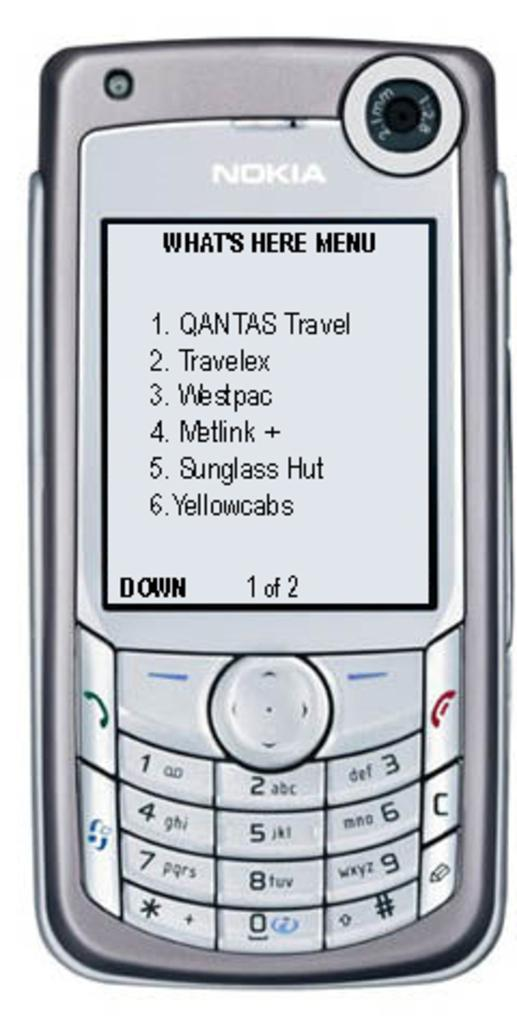<image>
Summarize the visual content of the image. Nokia phone that says What's Here Menu and says Down 1 of 2. 